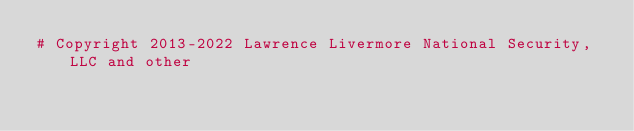<code> <loc_0><loc_0><loc_500><loc_500><_Python_># Copyright 2013-2022 Lawrence Livermore National Security, LLC and other</code> 